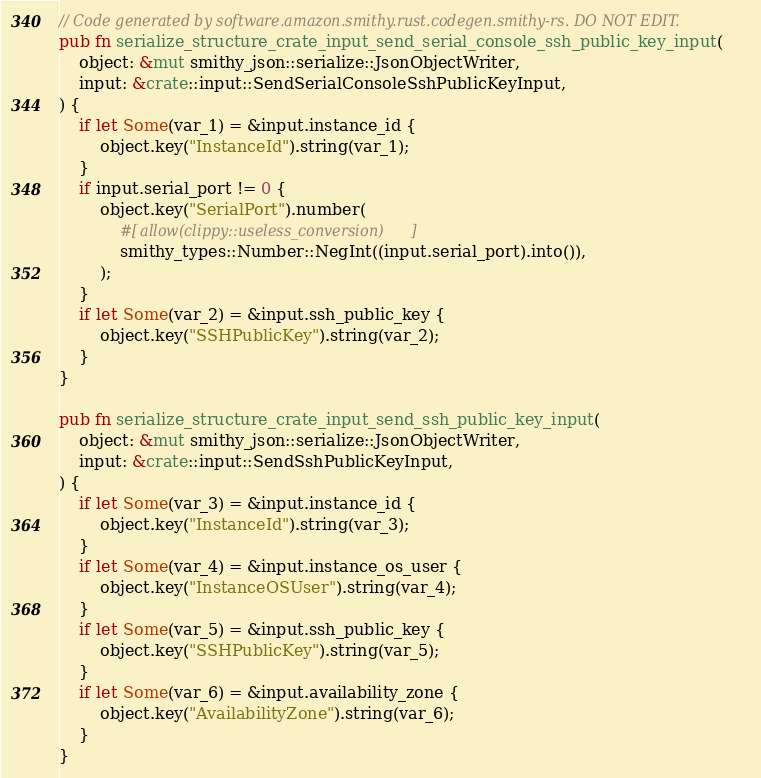Convert code to text. <code><loc_0><loc_0><loc_500><loc_500><_Rust_>// Code generated by software.amazon.smithy.rust.codegen.smithy-rs. DO NOT EDIT.
pub fn serialize_structure_crate_input_send_serial_console_ssh_public_key_input(
    object: &mut smithy_json::serialize::JsonObjectWriter,
    input: &crate::input::SendSerialConsoleSshPublicKeyInput,
) {
    if let Some(var_1) = &input.instance_id {
        object.key("InstanceId").string(var_1);
    }
    if input.serial_port != 0 {
        object.key("SerialPort").number(
            #[allow(clippy::useless_conversion)]
            smithy_types::Number::NegInt((input.serial_port).into()),
        );
    }
    if let Some(var_2) = &input.ssh_public_key {
        object.key("SSHPublicKey").string(var_2);
    }
}

pub fn serialize_structure_crate_input_send_ssh_public_key_input(
    object: &mut smithy_json::serialize::JsonObjectWriter,
    input: &crate::input::SendSshPublicKeyInput,
) {
    if let Some(var_3) = &input.instance_id {
        object.key("InstanceId").string(var_3);
    }
    if let Some(var_4) = &input.instance_os_user {
        object.key("InstanceOSUser").string(var_4);
    }
    if let Some(var_5) = &input.ssh_public_key {
        object.key("SSHPublicKey").string(var_5);
    }
    if let Some(var_6) = &input.availability_zone {
        object.key("AvailabilityZone").string(var_6);
    }
}
</code> 